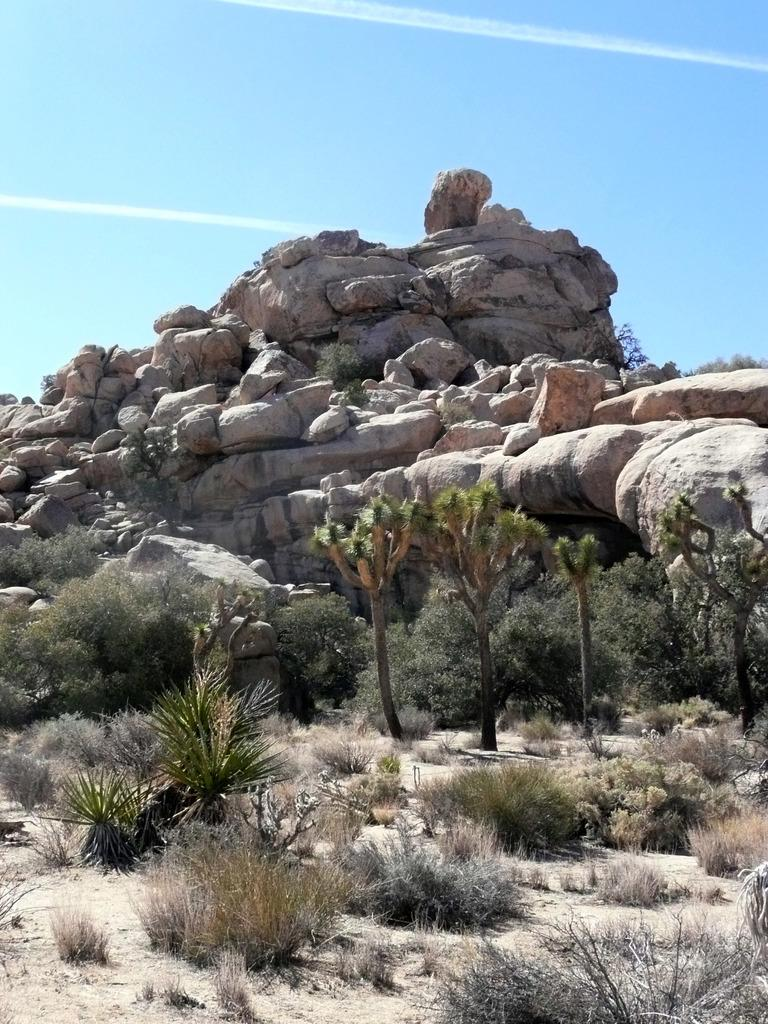What type of vegetation can be seen in the image? There are trees and plants in the image. What other natural elements are present in the image? There are rocks in the image. What can be seen in the background of the image? The sky is visible in the background of the image. Can you tell me how many glasses of eggnog are visible in the image? There is no eggnog present in the image. What type of cloud can be seen in the image? There is no cloud visible in the image; only the sky is visible in the background. 